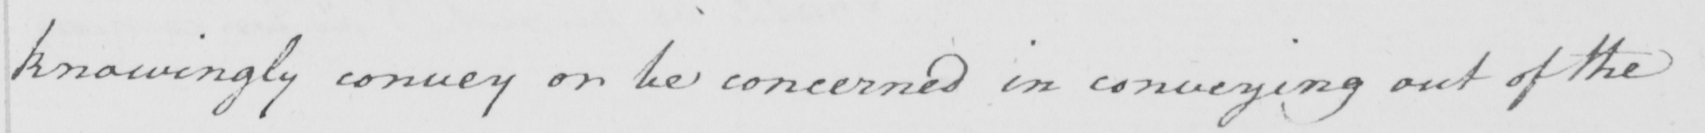What text is written in this handwritten line? knowingly convey or be concerned in conveying out of the 